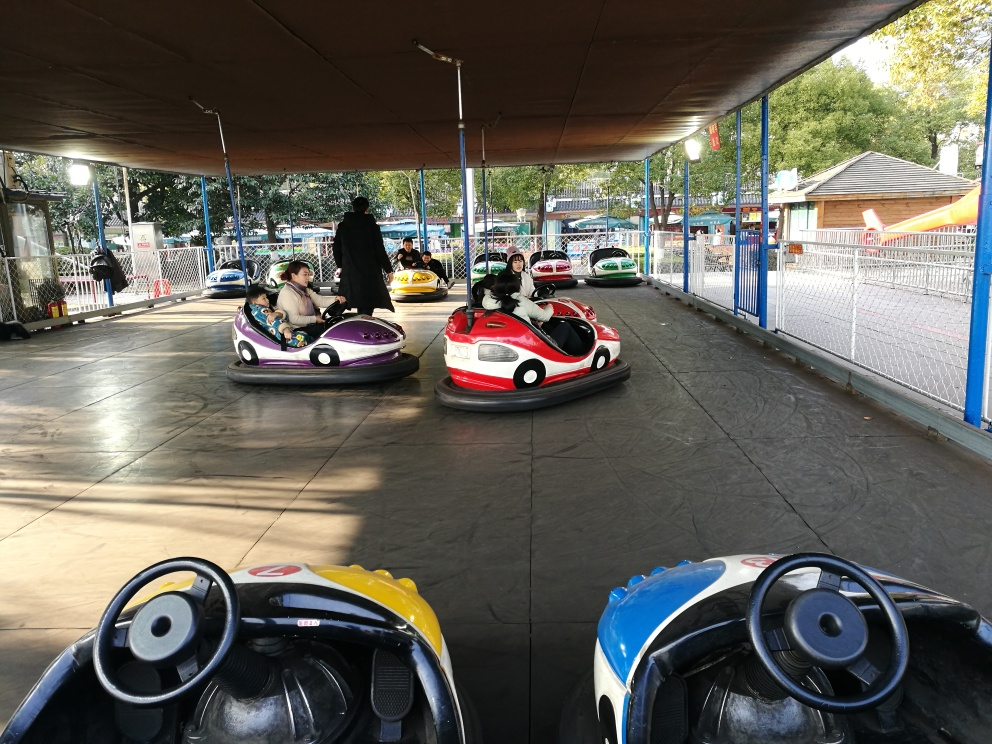What activity is happening in this picture? The image shows people engaging in a fun activity at an amusement park, specifically riding bumper cars. Participants are maneuvering their vehicles around a defined area, with the intent of lightly bumping into one another in a playful manner. 